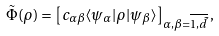<formula> <loc_0><loc_0><loc_500><loc_500>\tilde { \Phi } ( \rho ) = \left [ c _ { \alpha \beta } \langle \psi _ { \alpha } | \rho | \psi _ { \beta } \rangle \right ] _ { \alpha , \beta = \overline { 1 , \tilde { d } } } ,</formula> 